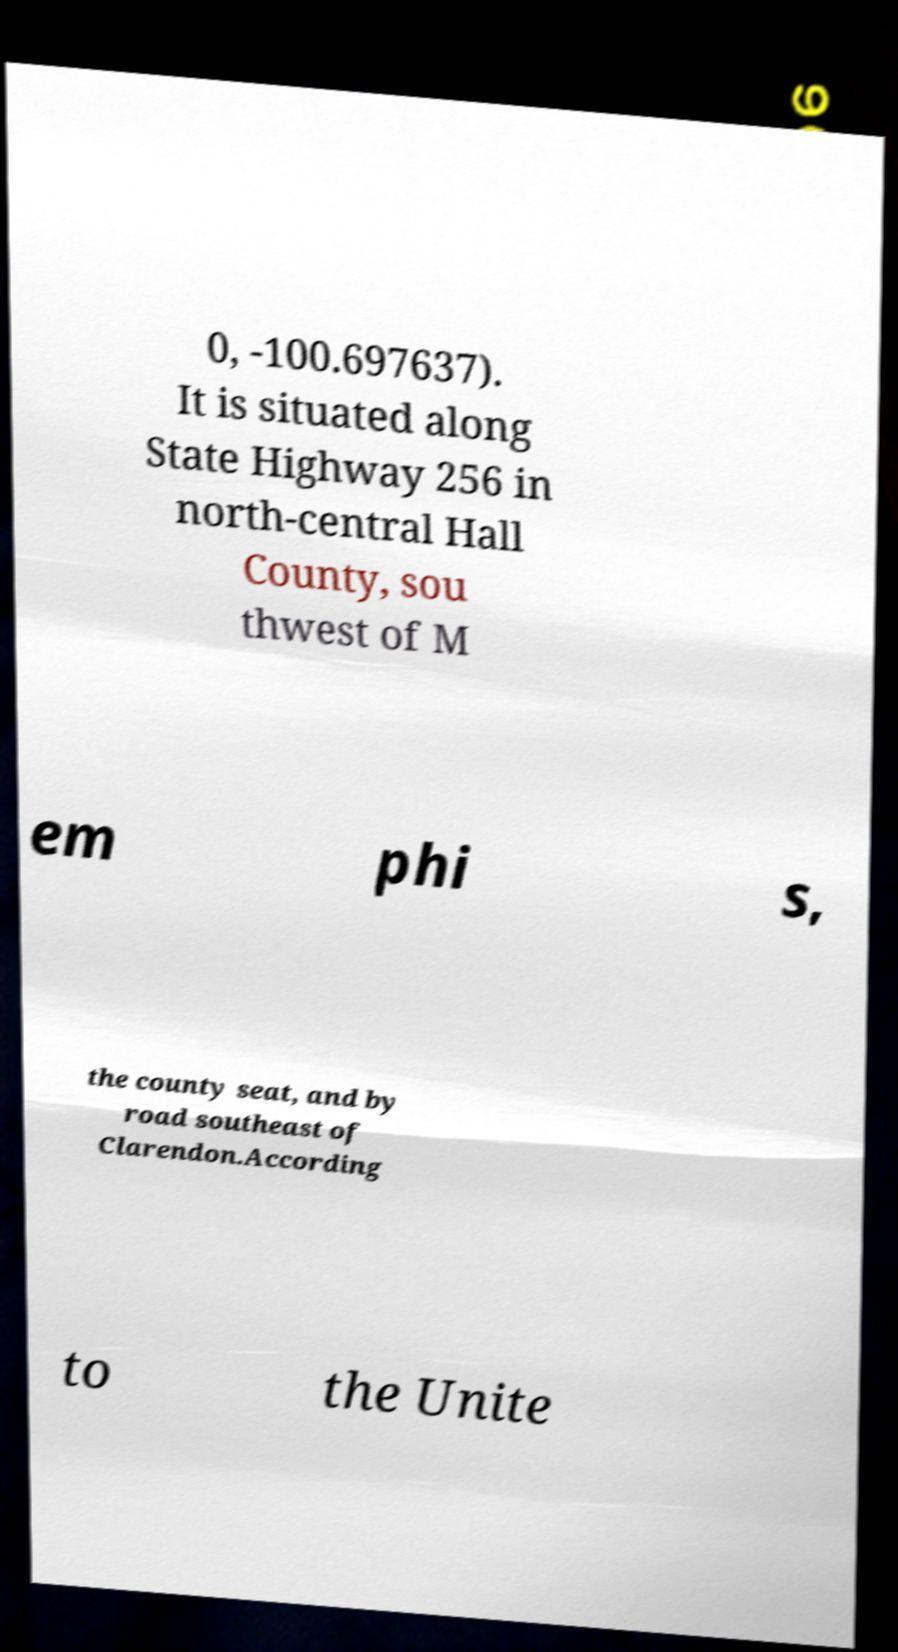What messages or text are displayed in this image? I need them in a readable, typed format. 0, -100.697637). It is situated along State Highway 256 in north-central Hall County, sou thwest of M em phi s, the county seat, and by road southeast of Clarendon.According to the Unite 